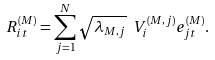<formula> <loc_0><loc_0><loc_500><loc_500>R _ { i t } ^ { ( M ) } = \sum _ { j = 1 } ^ { N } \sqrt { \lambda _ { M , j } } \ V _ { i } ^ { ( M , j ) } e _ { j t } ^ { ( M ) } .</formula> 